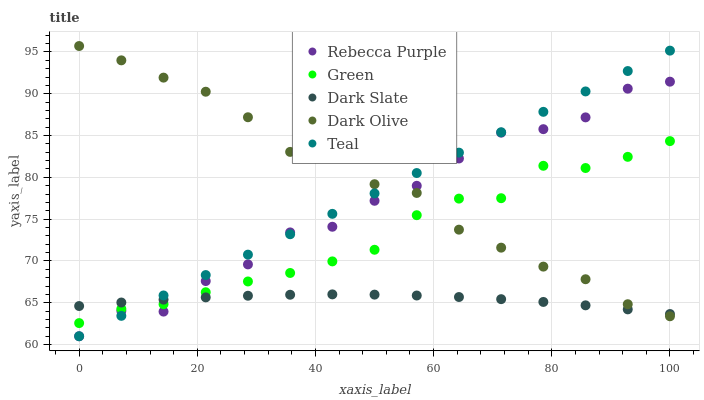Does Dark Slate have the minimum area under the curve?
Answer yes or no. Yes. Does Dark Olive have the maximum area under the curve?
Answer yes or no. Yes. Does Green have the minimum area under the curve?
Answer yes or no. No. Does Green have the maximum area under the curve?
Answer yes or no. No. Is Teal the smoothest?
Answer yes or no. Yes. Is Rebecca Purple the roughest?
Answer yes or no. Yes. Is Dark Olive the smoothest?
Answer yes or no. No. Is Dark Olive the roughest?
Answer yes or no. No. Does Rebecca Purple have the lowest value?
Answer yes or no. Yes. Does Dark Olive have the lowest value?
Answer yes or no. No. Does Dark Olive have the highest value?
Answer yes or no. Yes. Does Green have the highest value?
Answer yes or no. No. Does Green intersect Rebecca Purple?
Answer yes or no. Yes. Is Green less than Rebecca Purple?
Answer yes or no. No. Is Green greater than Rebecca Purple?
Answer yes or no. No. 